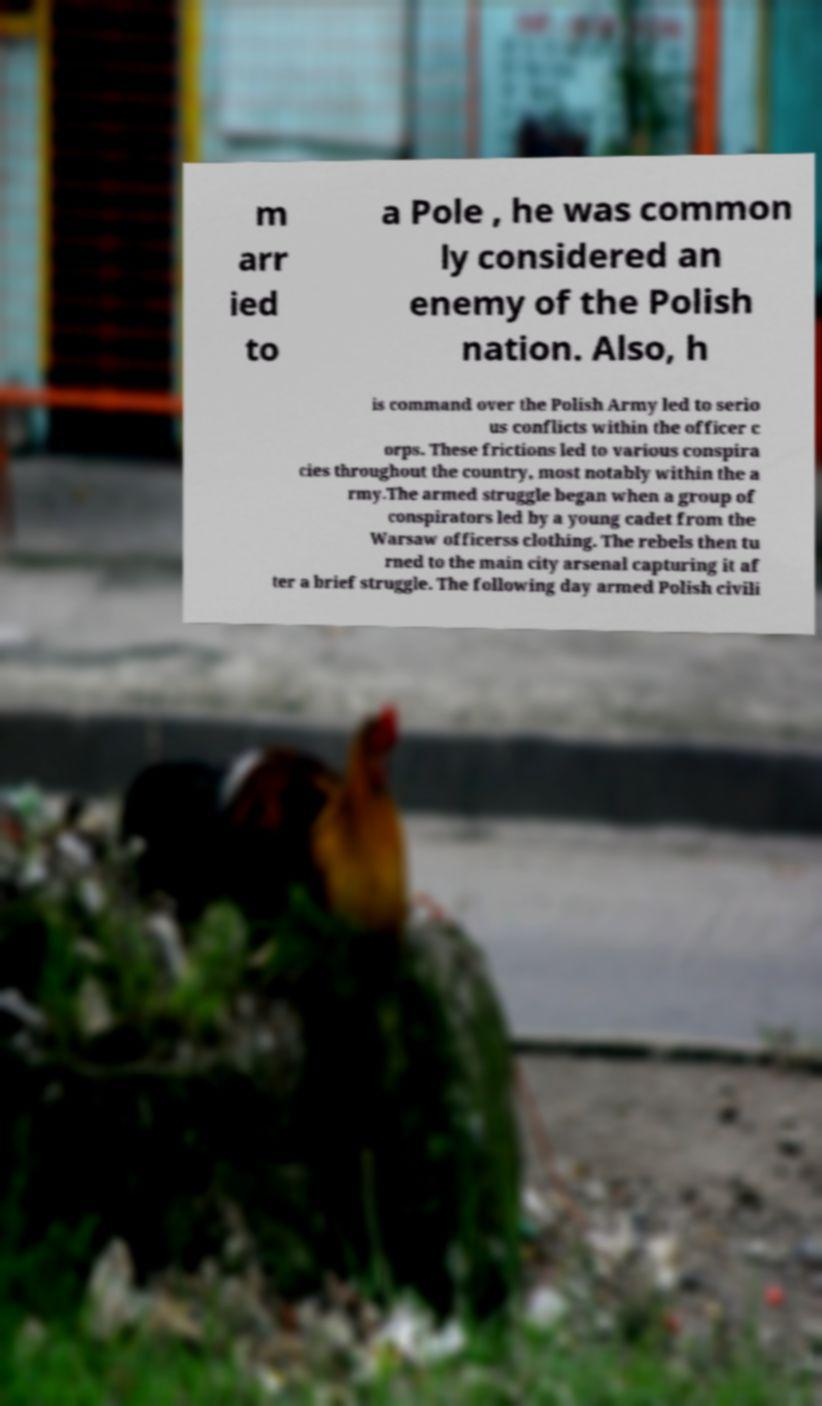Could you assist in decoding the text presented in this image and type it out clearly? m arr ied to a Pole , he was common ly considered an enemy of the Polish nation. Also, h is command over the Polish Army led to serio us conflicts within the officer c orps. These frictions led to various conspira cies throughout the country, most notably within the a rmy.The armed struggle began when a group of conspirators led by a young cadet from the Warsaw officerss clothing. The rebels then tu rned to the main city arsenal capturing it af ter a brief struggle. The following day armed Polish civili 